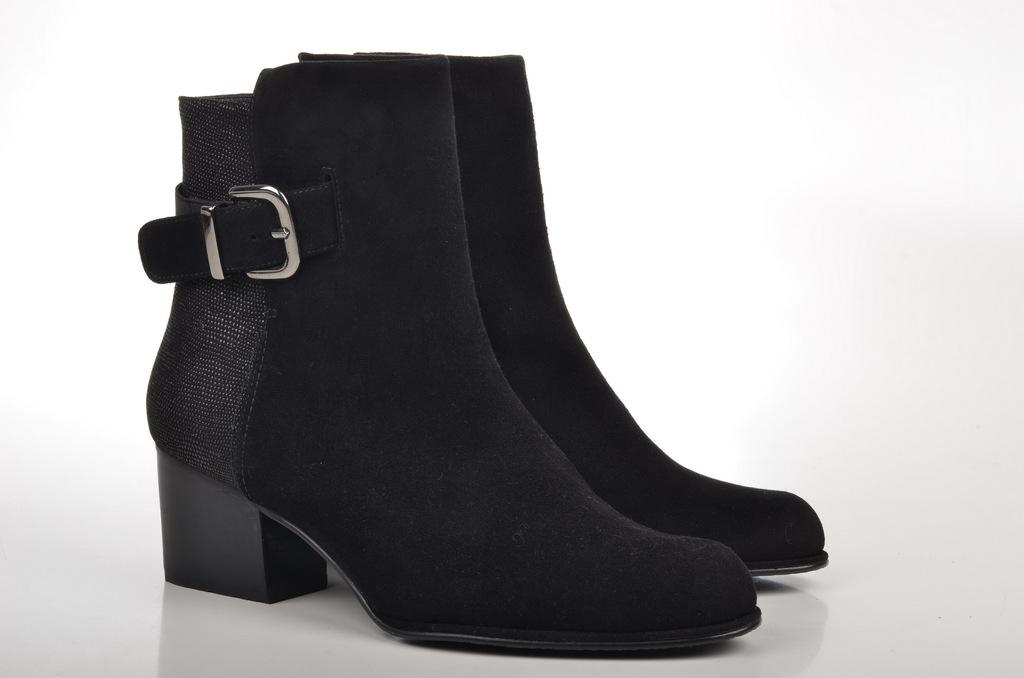What type of footwear is visible in the image? There is a pair of shoes in the image. What color are the shoes? The shoes are black in color. What is the color of the surface on which the shoes are placed? The shoes are on a white surface. How does the police officer increase the size of the shoes in the image? There is no police officer present in the image, and the size of the shoes cannot be increased in the image. 